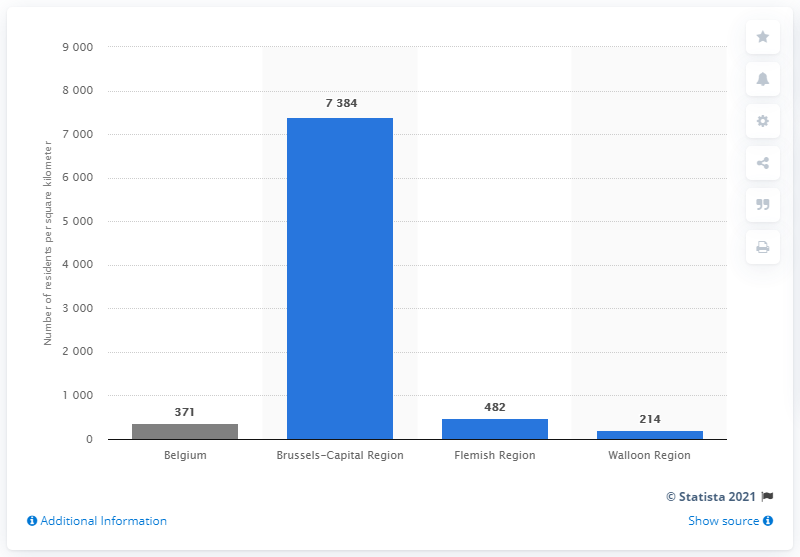Highlight a few significant elements in this photo. The Walloon Region had a population density of approximately 214 people per square kilometer. It is likely not suitable for those seeking peace and quiet if they choose to reside in the Brussels-Capital Region. 